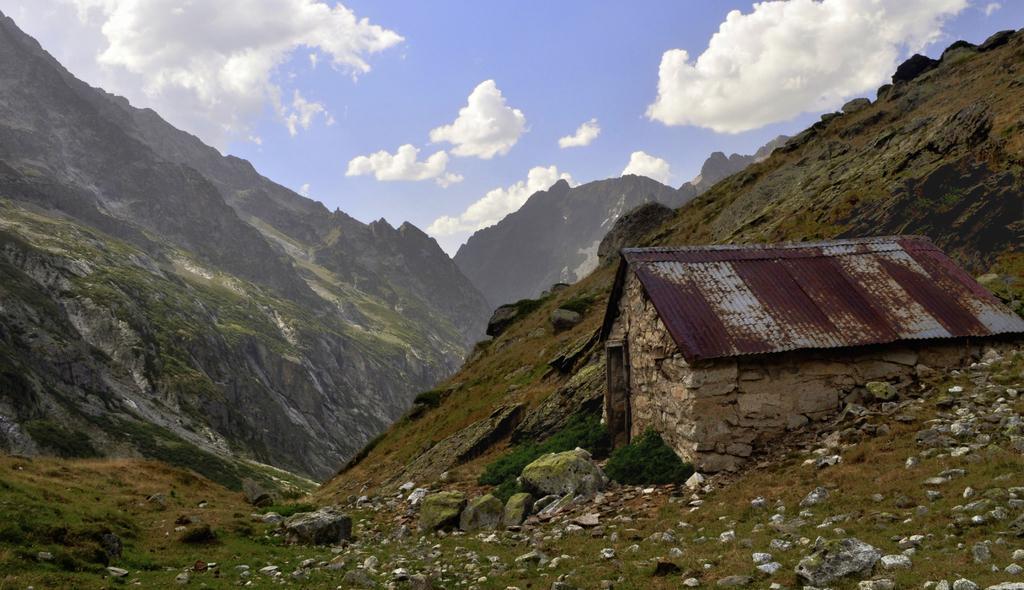Please provide a concise description of this image. In the foreground of this image, there is a hut on the cliff. We can also see stones, grass in the foreground. In the background, there are mountains, sky and the cloud. 